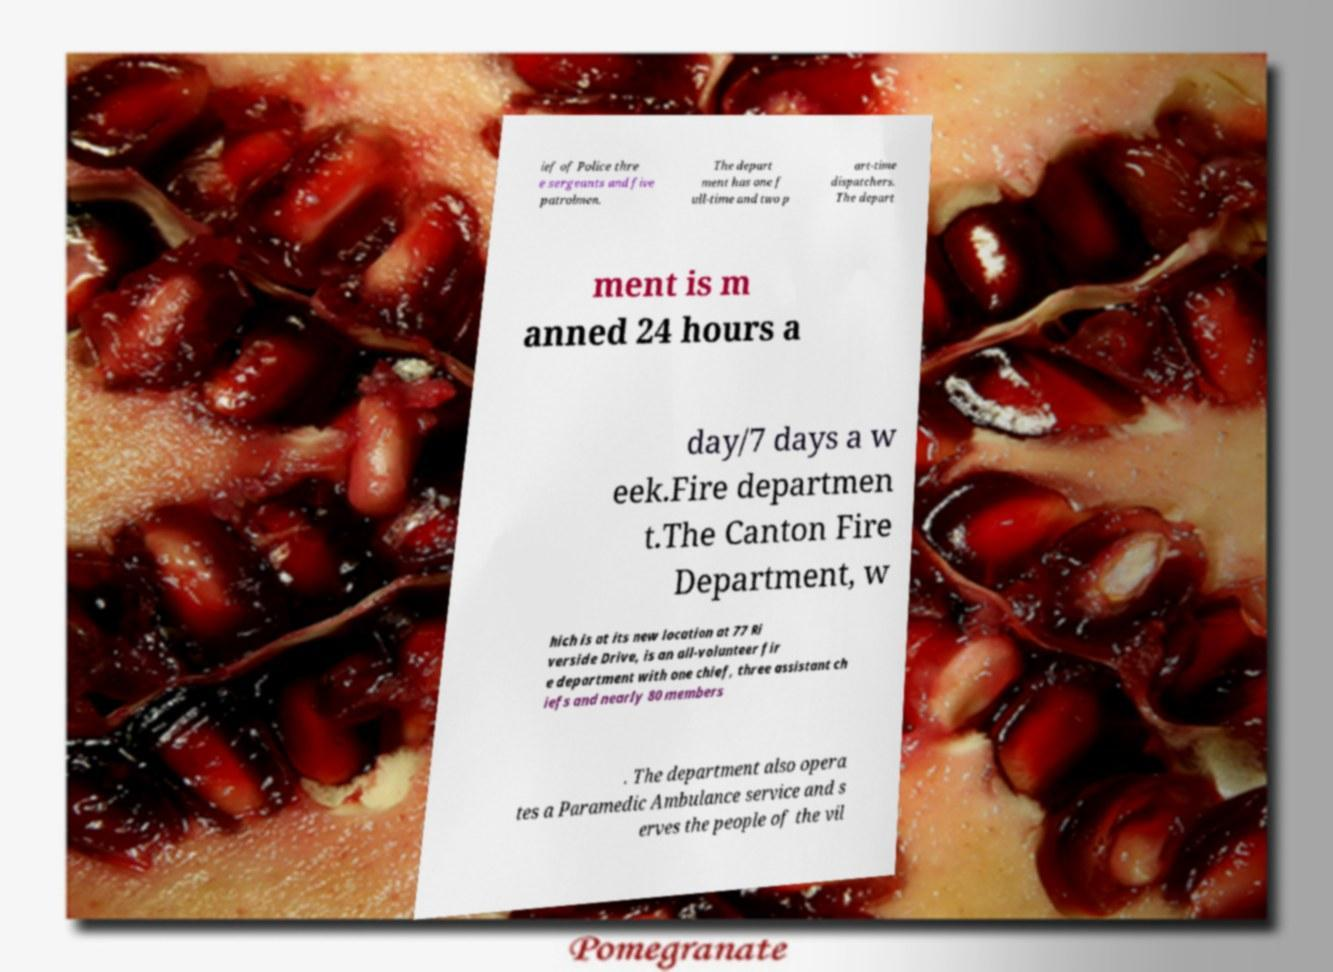For documentation purposes, I need the text within this image transcribed. Could you provide that? ief of Police thre e sergeants and five patrolmen. The depart ment has one f ull-time and two p art-time dispatchers. The depart ment is m anned 24 hours a day/7 days a w eek.Fire departmen t.The Canton Fire Department, w hich is at its new location at 77 Ri verside Drive, is an all-volunteer fir e department with one chief, three assistant ch iefs and nearly 80 members . The department also opera tes a Paramedic Ambulance service and s erves the people of the vil 